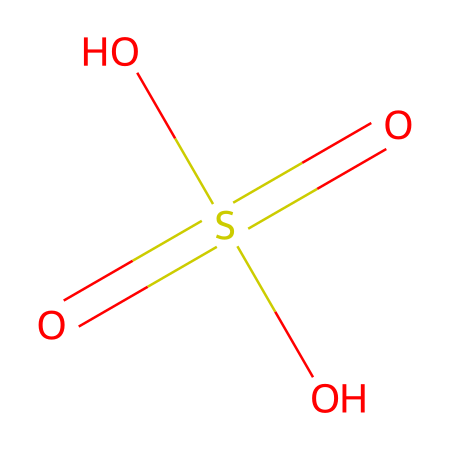How many hydrogen atoms are in this chemical? Analyzing the SMILES, O=S(=O)(O)O indicates three oxygen atoms and one sulfur atom. Hydrogen atoms can be deduced from the hydroxyl (OH) groups present. There are three OH groups attached to the sulfur, meaning there are three hydrogen atoms.
Answer: three What is the chemical's name? The chemical represented by the given SMILES is sulfuric acid, as indicated by the presence of the sulfur atom bonded with double bonded oxygens and hydroxyl groups.
Answer: sulfuric acid What is the oxidation state of sulfur in this molecule? In sulfuric acid, the sulfur atom is bonded to four oxygen atoms. The two double bonds with oxygen contribute -2 to the sulfur's oxidation state. Each hydroxyl group contributes -1, giving a total of +6 for sulfur's oxidation state. Thus, the oxidation state is +6.
Answer: +6 What type of acid is this chemical? Sulfuric acid is a strong acid due to its complete ionization in water, as illustrated by the presence of the hydroxyl groups which release H+ ions easily.
Answer: strong acid How many double bonds are present in this chemical structure? In the SMILES O=S(=O)(O)O, the "=" symbol indicates the presence of double bonds. The sulfur atom has two double bonds to oxygen, so there are two double bonds in total.
Answer: two What role does sulfuric acid play in battery manufacturing? In battery manufacturing, especially for lead-acid batteries, sulfuric acid serves as the electrolyte which participates in the electrochemical reactions, allowing for the flow of electrical current.
Answer: electrolyte Is this chemical hazardous? Yes, sulfuric acid is considered hazardous due to its strong corrosive properties, which can lead to severe chemical burns as well as other harmful effects on health and the environment.
Answer: yes 